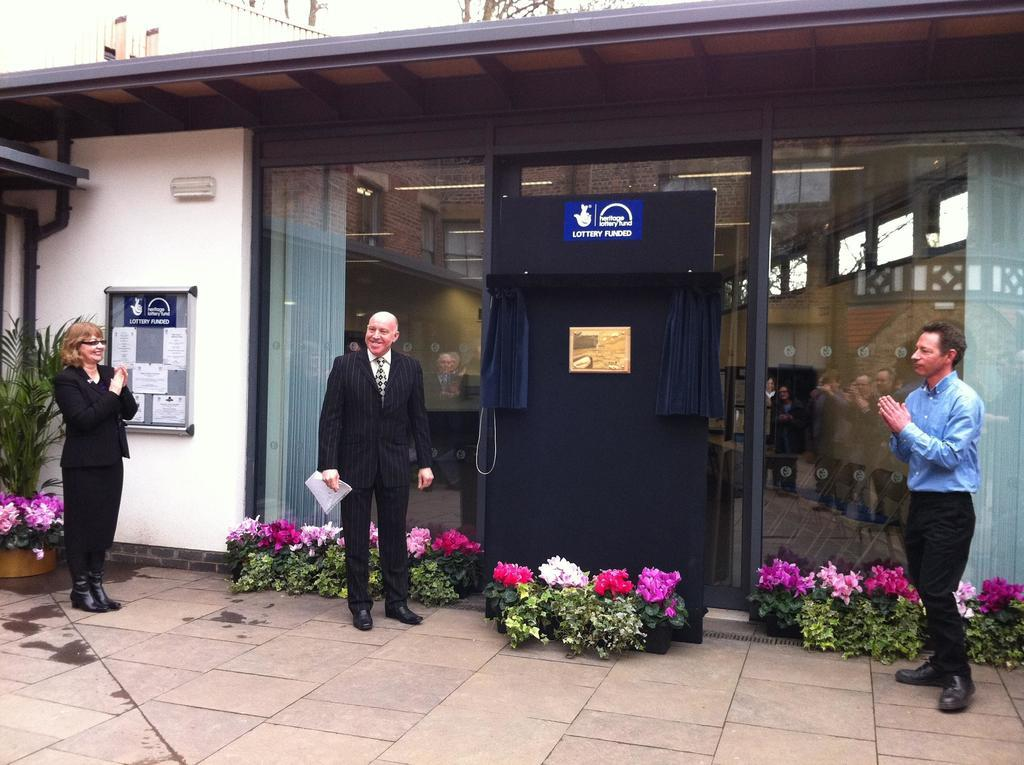<image>
Present a compact description of the photo's key features. Blue sign with Heritage lottery fund lottery funded with a hand with crossed fingers. 